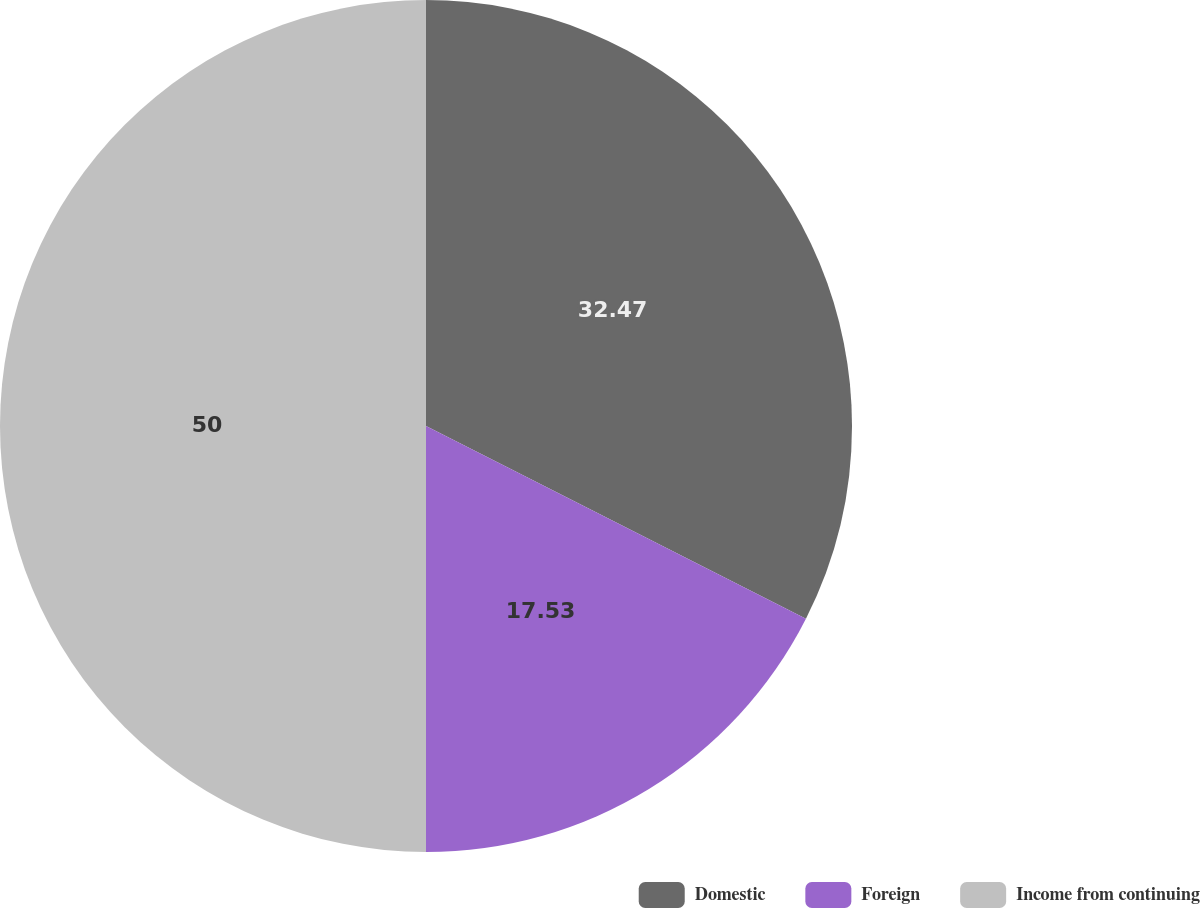<chart> <loc_0><loc_0><loc_500><loc_500><pie_chart><fcel>Domestic<fcel>Foreign<fcel>Income from continuing<nl><fcel>32.47%<fcel>17.53%<fcel>50.0%<nl></chart> 